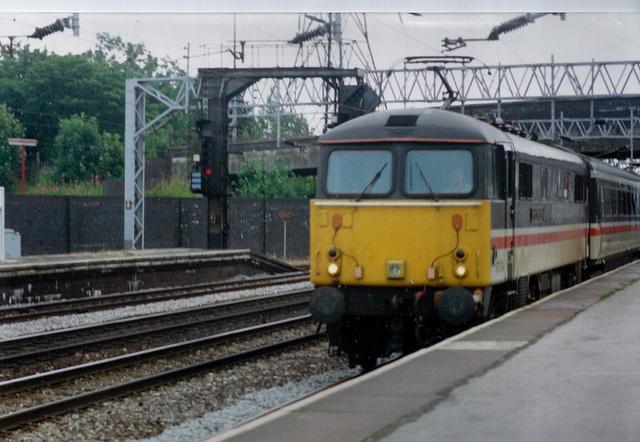How many cars?
Give a very brief answer. 0. 